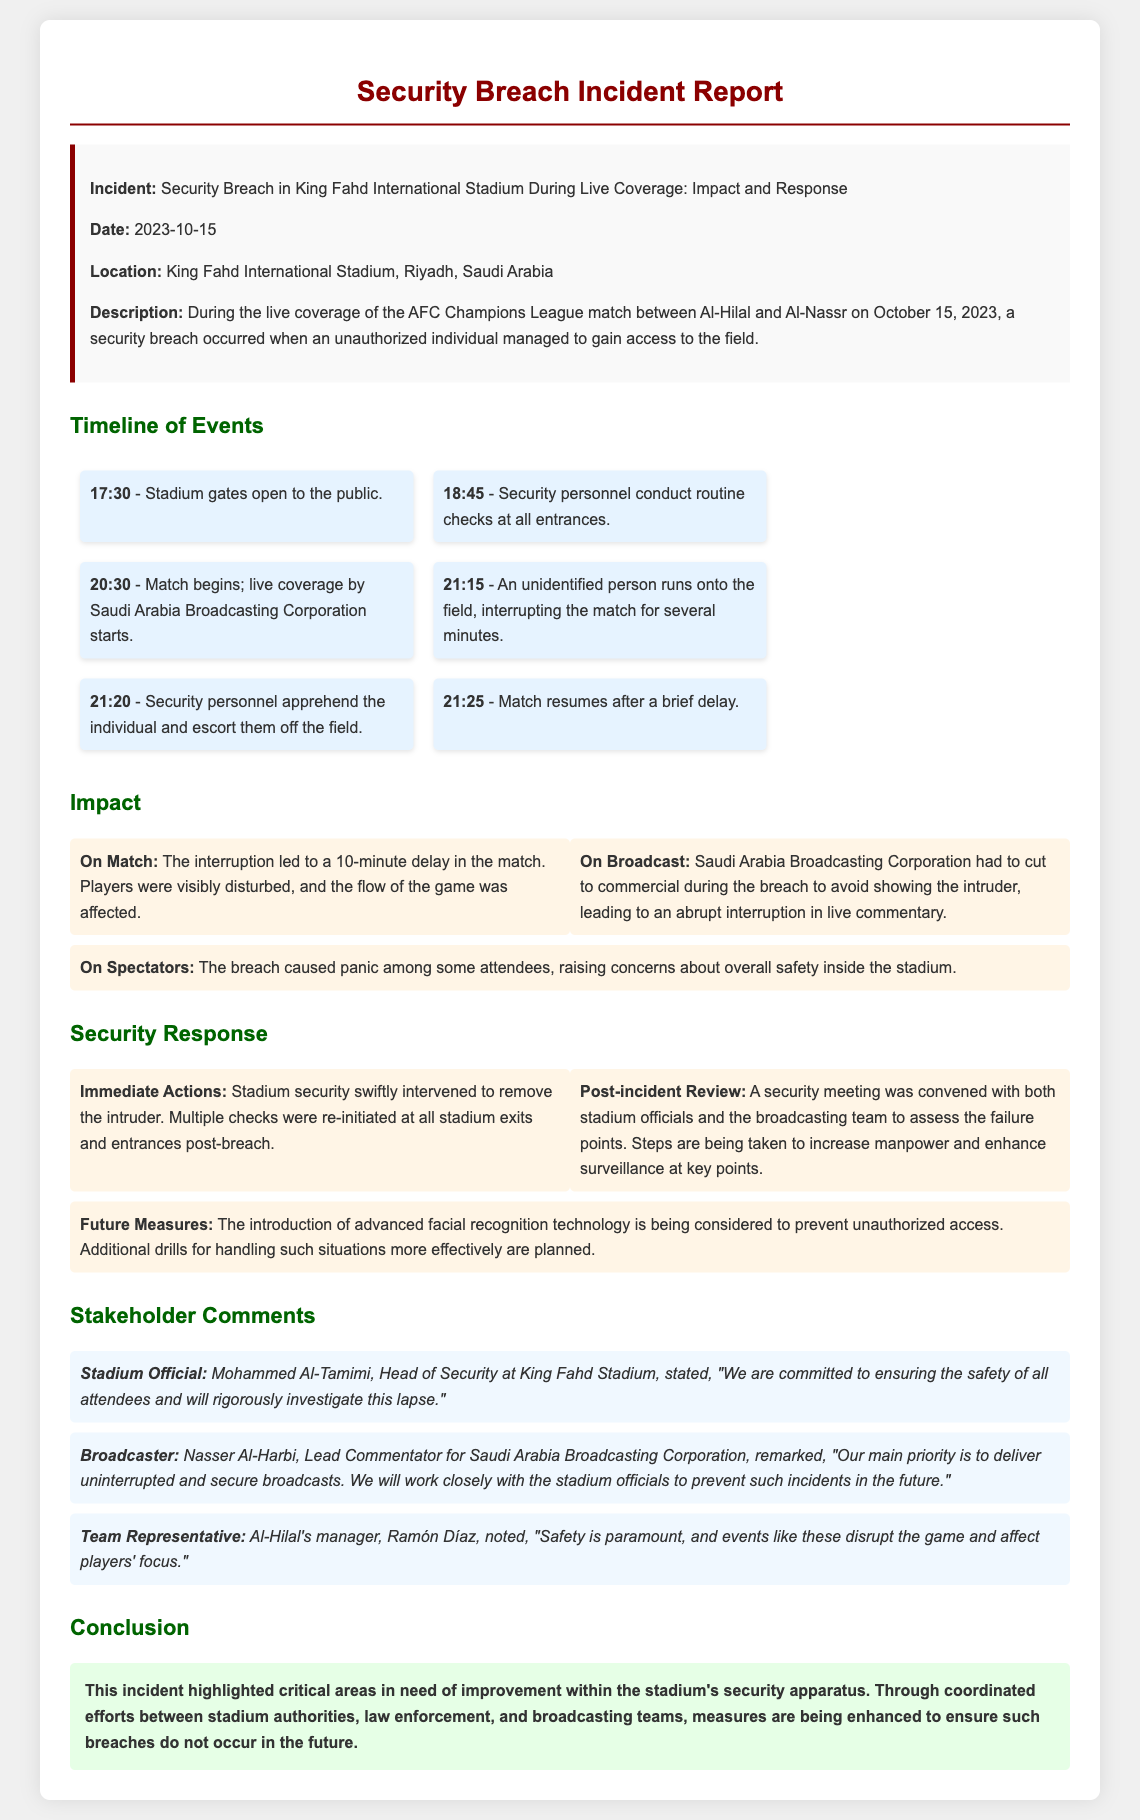What was the date of the incident? The incident occurred on October 15, 2023, as stated in the document.
Answer: October 15, 2023 What event was taking place during the security breach? The breach occurred during the AFC Champions League match between Al-Hilal and Al-Nassr.
Answer: AFC Champions League match What time did the match begin? The match began at 8:30 PM, which is noted in the timeline of events.
Answer: 20:30 How long was the match delayed due to the breach? The match was interrupted for 10 minutes.
Answer: 10 minutes What was an immediate action taken by security? Stadium security swiftly intervened to remove the intruder.
Answer: Remove the intruder Who is the Head of Security at King Fahd Stadium? Mohammed Al-Tamimi is identified as the Head of Security in the stakeholder comments.
Answer: Mohammed Al-Tamimi What technology is being considered for future security measures? The introduction of advanced facial recognition technology is being considered.
Answer: Advanced facial recognition technology What concern did spectators have due to the breach? The breach caused panic among some attendees, raising safety concerns.
Answer: Safety concerns How did Saudi Arabia Broadcasting Corporation respond during the breach? They had to cut to commercial during the breach to avoid showing the intruder.
Answer: Cut to commercial 